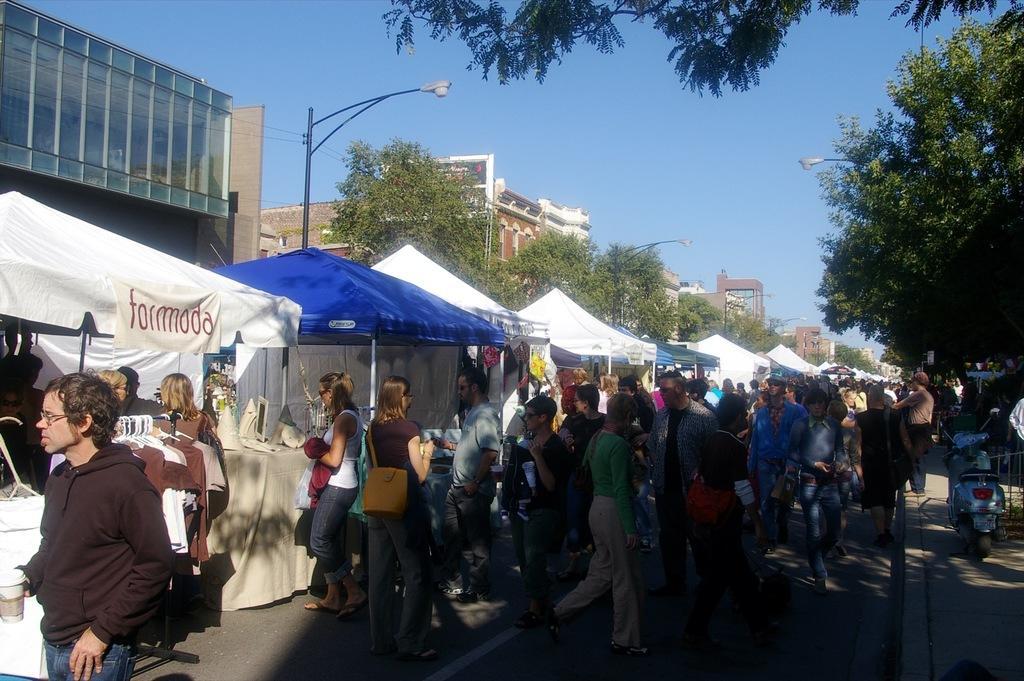Could you give a brief overview of what you see in this image? In this image I can see people among them some are holding objects in hands. Here I can see stalls, trees, street lights, buildings and a vehicle. In the background I can see the sky. 